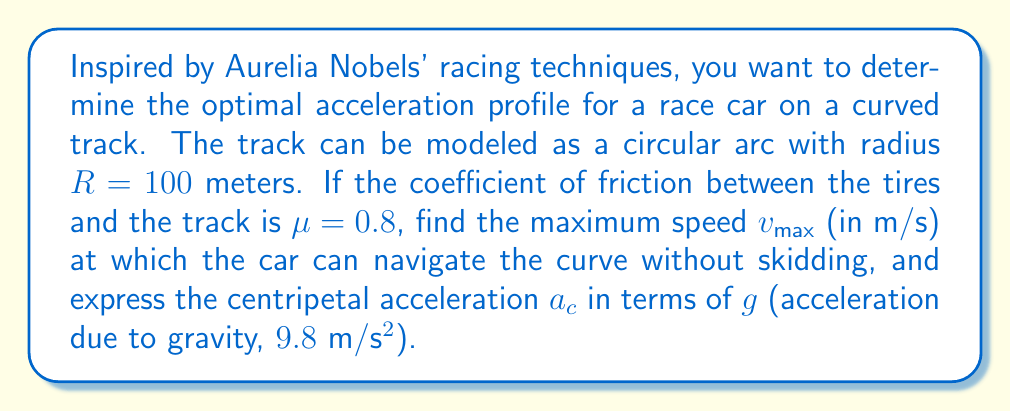Teach me how to tackle this problem. Let's approach this step-by-step:

1) For a car to navigate a curve without skidding, the centripetal force must be less than or equal to the force of friction:

   $$F_c \leq F_f$$

2) The centripetal force is given by:
   
   $$F_c = \frac{mv^2}{R}$$

   where $m$ is the mass of the car, $v$ is the velocity, and $R$ is the radius of curvature.

3) The force of friction is given by:
   
   $$F_f = \mu mg$$

   where $\mu$ is the coefficient of friction and $g$ is the acceleration due to gravity.

4) At the maximum speed, these forces are equal:

   $$\frac{mv_{max}^2}{R} = \mu mg$$

5) We can cancel out $m$ on both sides:

   $$\frac{v_{max}^2}{R} = \mu g$$

6) Solving for $v_{max}$:

   $$v_{max} = \sqrt{\mu gR}$$

7) Substituting the given values:

   $$v_{max} = \sqrt{0.8 \cdot 9.8 \cdot 100} = \sqrt{784} \approx 28.0 \text{ m/s}$$

8) The centripetal acceleration is given by:

   $$a_c = \frac{v_{max}^2}{R} = \frac{784}{100} = 7.84 \text{ m/s²}$$

9) Expressing $a_c$ in terms of $g$:

   $$a_c = \frac{7.84}{9.8}g \approx 0.8g$$
Answer: The maximum speed $v_{max}$ is approximately 28.0 m/s, and the centripetal acceleration $a_c$ is 0.8g. 